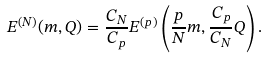<formula> <loc_0><loc_0><loc_500><loc_500>E ^ { ( N ) } ( m , Q ) = \frac { C _ { N } } { C _ { p } } E ^ { ( p ) } \left ( \frac { p } { N } m , \frac { C _ { p } } { C _ { N } } Q \right ) .</formula> 